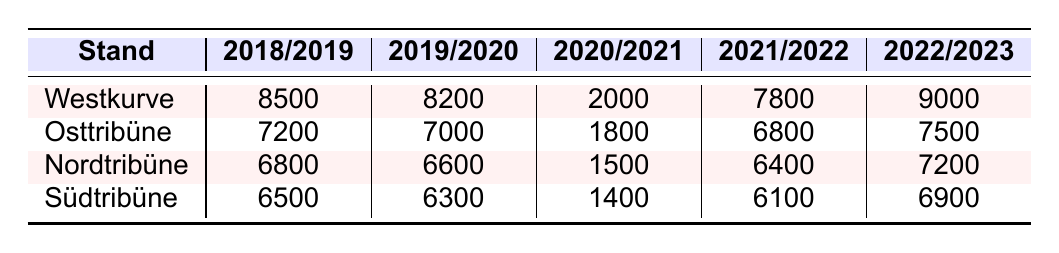What was the highest attendance in the Westkurve during the 2018/2019 season? The data for the Westkurve in the 2018/2019 season shows an attendance of 8500, which is the highest value for that season in that stand.
Answer: 8500 Which stand had the lowest attendance in the 2020/2021 season? In the 2020/2021 season, the South Tribune (Südtribüne) had the lowest attendance with 1400, compared to the other stands.
Answer: Südtribüne What was the total attendance for all stands in the 2022/2023 season? The total attendance for the 2022/2023 season can be calculated by adding the attendances of all four stands: 9000 + 7500 + 7200 + 6900 = 30600.
Answer: 30600 Did the attendance in the Osttribüne increase or decrease from the 2019/2020 season to the 2022/2023 season? The attendance in the Osttribüne was 7000 in the 2019/2020 season and increased to 7500 in the 2022/2023 season, indicating an increase.
Answer: Increased What is the average attendance for the Nordtribüne over all the seasons? To find the average for the Nordtribüne, add the attendance values: 6800 + 6600 + 1500 + 6400 + 7200 = 31000, and then divide by 5 (the number of seasons), giving an average of 6200.
Answer: 6200 Which stand had the highest attendance in the 2021/2022 season? The Westkurve had the highest attendance in the 2021/2022 season with 7800 fans, compared to other stands.
Answer: Westkurve What was the difference in attendance between the Südtribüne and the Westkurve in the 2019/2020 season? The Westkurve had 8200 and the Südtribüne had 6300 in the 2019/2020 season. The difference can be calculated as 8200 - 6300 = 1900.
Answer: 1900 How many seasons had an attendance above 7000 in the Nordtribüne? The Nordtribüne had attendance above 7000 in the seasons 2018/2019, 2019/2020, and 2022/2023, totaling 3 seasons.
Answer: 3 Which season saw the most significant drop in attendance for the Osttribüne compared to the previous season? The Osttribüne's attendance dropped from 7200 in 2018/2019 to 1800 in 2020/2021, a change of 5400, which is the most significant drop.
Answer: 5400 How does the total attendance across all seasons compare between the Westkurve and the Südtribüne? The Westkurve total attendance is 8500 + 8200 + 2000 + 7800 + 9000 = 35500, while the Südtribüne total is 6500 + 6300 + 1400 + 6100 + 6900 = 28200. Since 35500 > 28200, the Westkurve has a higher total attendance.
Answer: Westkurve has higher total attendance 